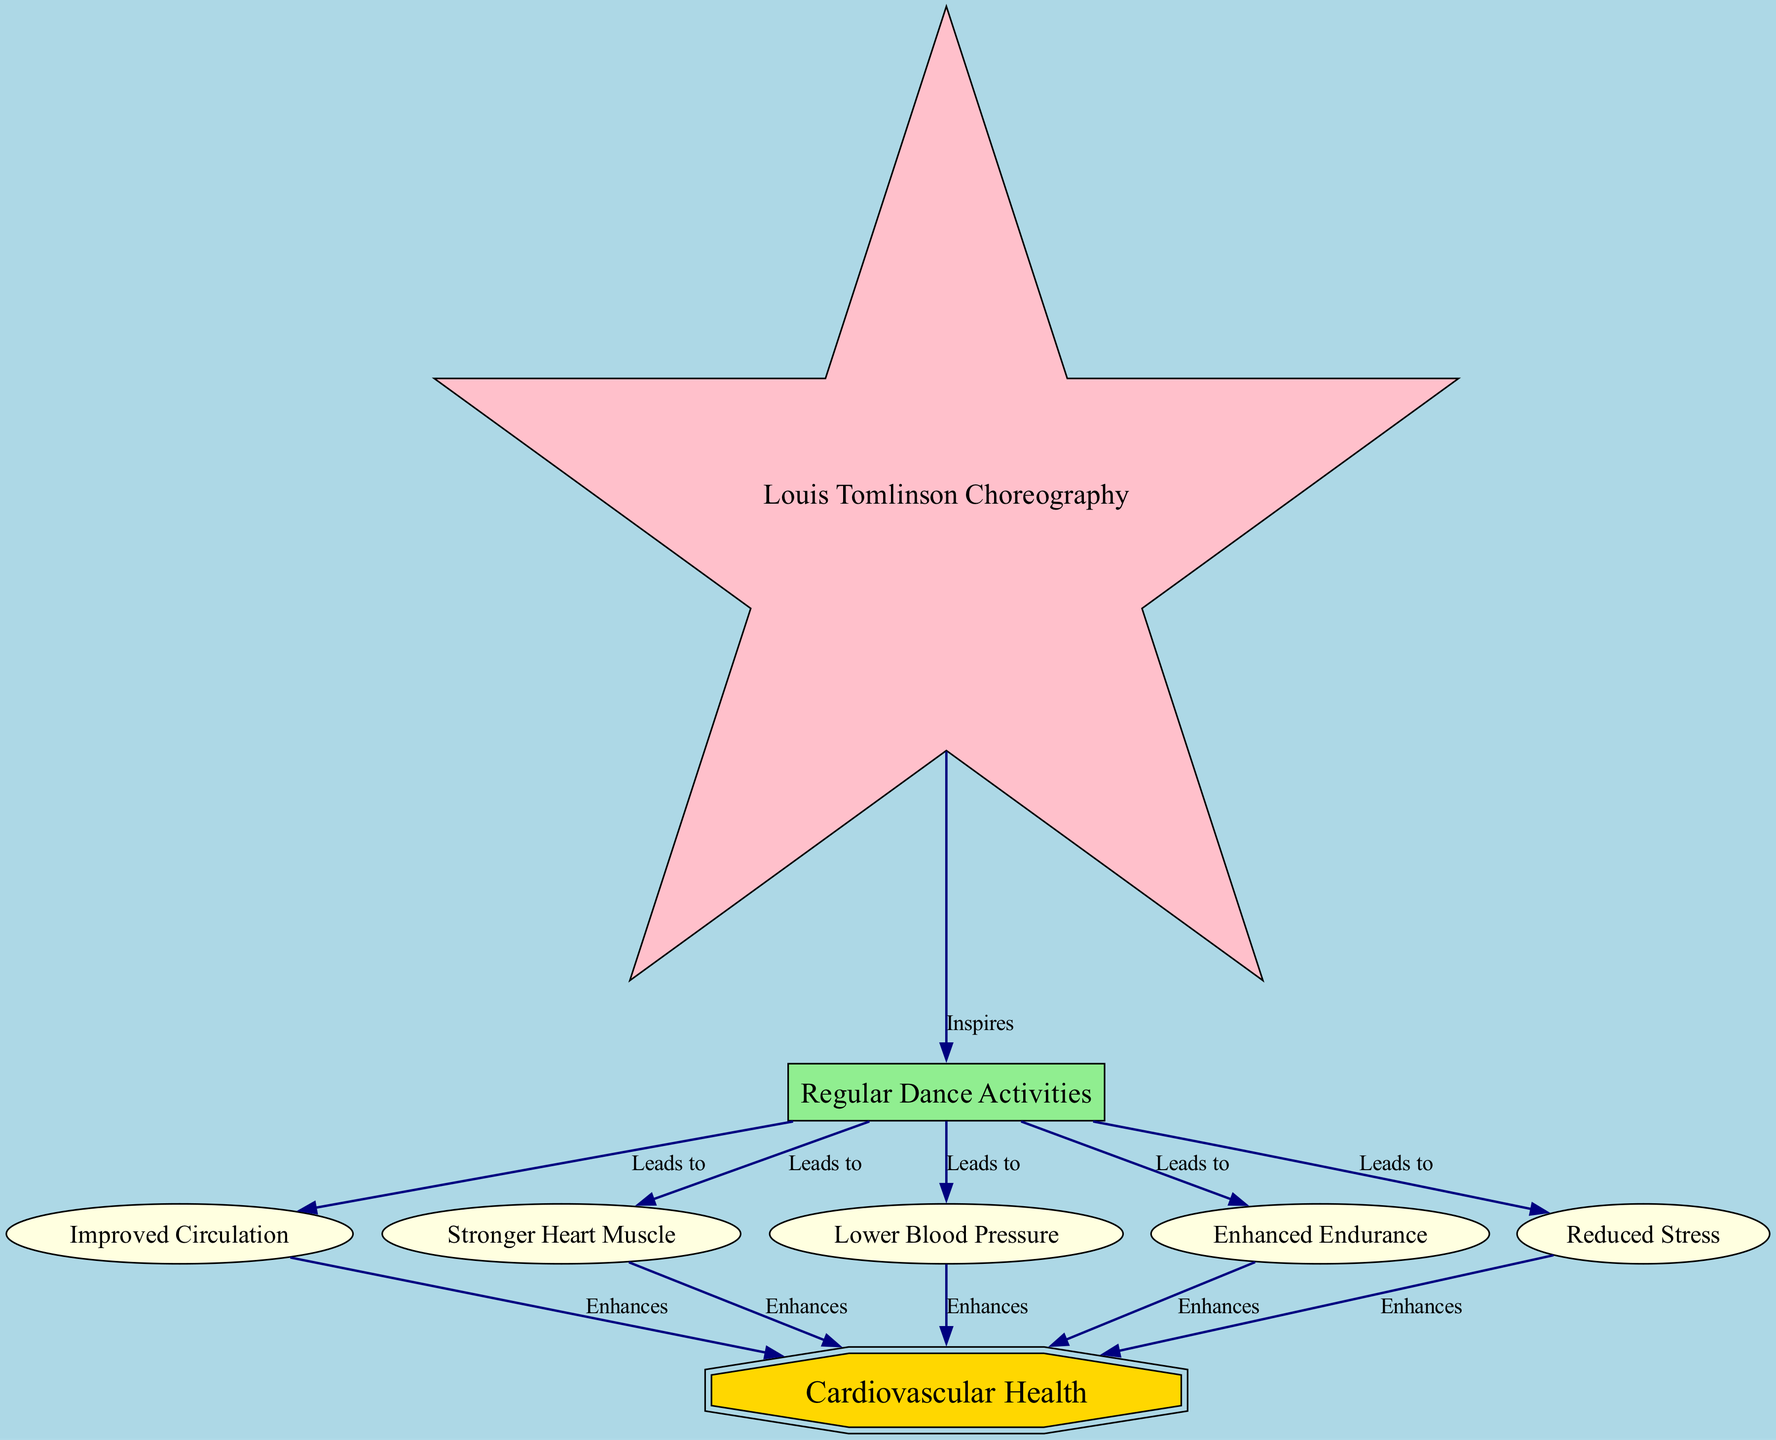What is the main health focus of the diagram? The diagram centers around "Cardiovascular Health," which is indicated as the key node in the diagram, shown as a doubleoctagon in gold.
Answer: Cardiovascular Health How many nodes are there in the diagram? By counting each unique node in the diagram, we can see that there are 7 nodes involved.
Answer: 7 What does Louis Tomlinson's choreography do in the context of this diagram? The diagram illustrates that Louis Tomlinson's choreography "Inspires" regular dance activities, establishing a direct relationship between the two nodes.
Answer: Inspires Which benefit is associated with "Regular Dance Activities" that contributes to cardiovascular health? "Lower Blood Pressure" is one of the benefits that results from regular dance activities, as shown in the direct connection stemming from that node.
Answer: Lower Blood Pressure How many benefits enhance cardiovascular health in the diagram? The diagram shows five benefits that enhance cardiovascular health, all stemming from various nodes leading into the main "Cardiovascular Health" node.
Answer: 5 What leads to improved circulation? "Regular Dance Activities" leads to "Improved Circulation," as indicated by the directed edge between these two nodes in the diagram.
Answer: Regular Dance Activities Which benefit contributes to cardiovascular health by reducing mental strain? "Reduced Stress" contributes to cardiovascular health by addressing mental strain, according to the connections shown in the diagram.
Answer: Reduced Stress What are the edges connecting 'Regular Dance Activities' to cardiovascular health benefits? The edges are: "Improved Circulation," "Stronger Heart Muscle," "Lower Blood Pressure," "Enhanced Endurance," and "Reduced Stress," each leading to the main cardiovascular health node.
Answer: Improved Circulation, Stronger Heart Muscle, Lower Blood Pressure, Enhanced Endurance, Reduced Stress Which benefit has the strongest positive impact on the heart muscle? "Stronger Heart Muscle" is the benefit most directly leading to an enhancement of cardiovascular health, emphasizing its strong positive impact.
Answer: Stronger Heart Muscle 